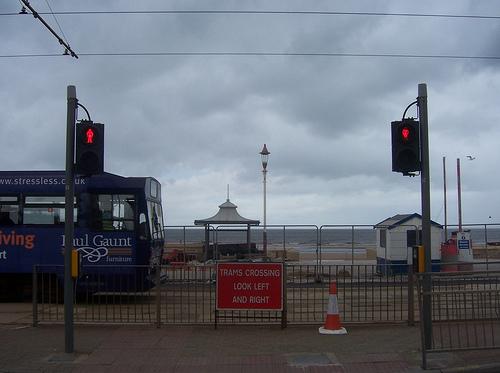Is the ocean or train in the foreground?
Quick response, please. Train. What crosses in this photo?
Be succinct. Trams. Is it sunny here?
Be succinct. No. 